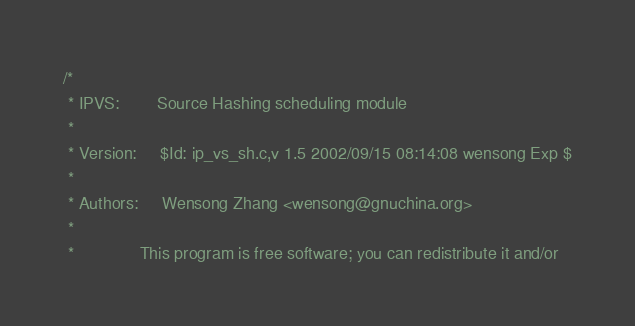Convert code to text. <code><loc_0><loc_0><loc_500><loc_500><_C_>/*
 * IPVS:        Source Hashing scheduling module
 *
 * Version:     $Id: ip_vs_sh.c,v 1.5 2002/09/15 08:14:08 wensong Exp $
 *
 * Authors:     Wensong Zhang <wensong@gnuchina.org>
 *
 *              This program is free software; you can redistribute it and/or</code> 